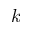<formula> <loc_0><loc_0><loc_500><loc_500>k</formula> 